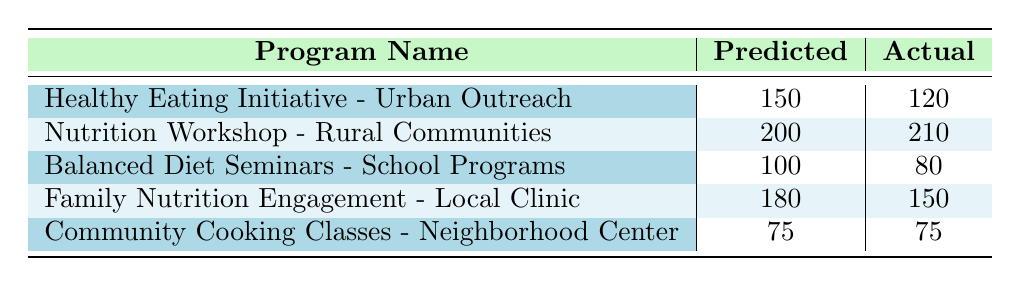What is the predicted participation for the "Nutrition Workshop - Rural Communities"? The predicted participation for a specific program is indicated in the "Predicted" column next to the relevant program name. For "Nutrition Workshop - Rural Communities", the predicted participation is 200.
Answer: 200 Which program had an actual participation that exceeded its predicted participation? To determine this, we compare the "Actual" column with the "Predicted" column for each program. The "Nutrition Workshop - Rural Communities" has an actual participation of 210, which is higher than its predicted participation of 200.
Answer: Nutrition Workshop - Rural Communities What is the difference in predicted and actual participation for the "Balanced Diet Seminars - School Programs"? The difference is calculated by subtracting the actual participation (80) from the predicted participation (100). So, the difference is 100 - 80 = 20.
Answer: 20 Is the actual participation for the "Community Cooking Classes - Neighborhood Center" equal to its predicted participation? We check the values in the "Actual" and "Predicted" columns for "Community Cooking Classes - Neighborhood Center". Both values are 75, indicating they are equal.
Answer: Yes What is the average actual participation rate across all programs? To calculate the average, sum the actual participation values (120 + 210 + 80 + 150 + 75 = 635) and divide by the number of programs (5). Thus, the average is 635 / 5 = 127.
Answer: 127 Which program had the lowest actual participation, and what was that number? By examining the "Actual" column values, the "Balanced Diet Seminars - School Programs" has the lowest actual participation at 80.
Answer: Balanced Diet Seminars - School Programs, 80 How many programs had a predicted participation greater than 150? We check the "Predicted" column for values greater than 150. The programs with predicted participation greater than 150 are "Healthy Eating Initiative - Urban Outreach" (150), "Nutrition Workshop - Rural Communities" (200), and "Family Nutrition Engagement - Local Clinic" (180), totaling 3 programs.
Answer: 3 What is the total predicted participation across all programs? To find the total predicted participation, we sum all values in the "Predicted" column: 150 + 200 + 100 + 180 + 75 = 705.
Answer: 705 Which programs had actual participation below their predicted participation? We compare each program's predicted and actual participation. The programs that had actual participation below their predicted participation are: "Healthy Eating Initiative - Urban Outreach" (120 vs 150) and "Balanced Diet Seminars - School Programs" (80 vs 100).
Answer: Healthy Eating Initiative - Urban Outreach, Balanced Diet Seminars - School Programs 